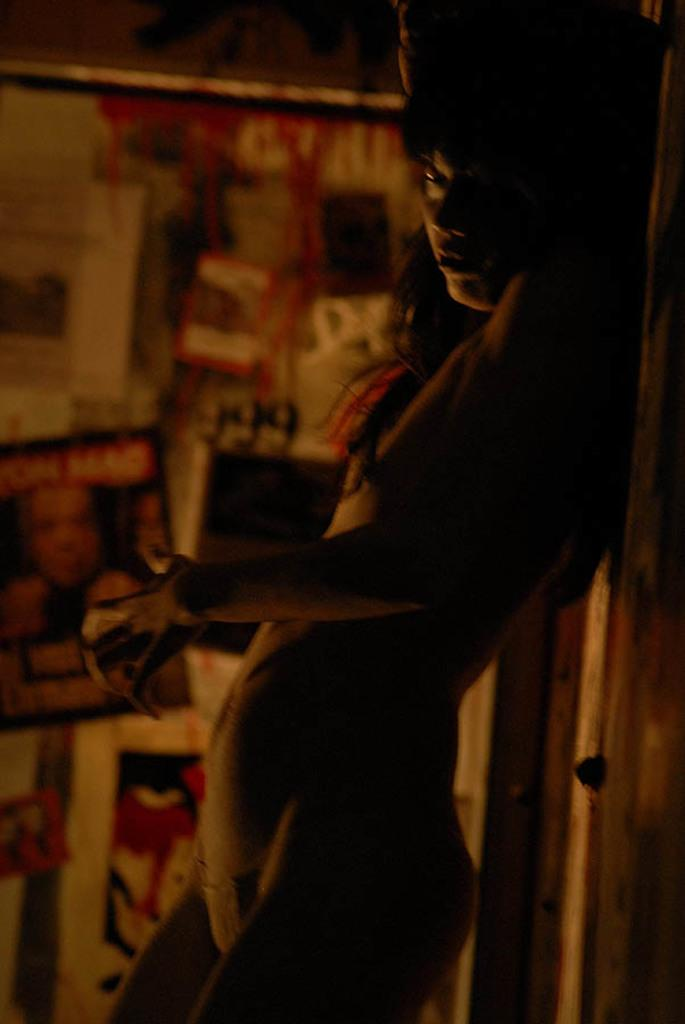What is the main subject of the image? There is a person standing in the image. Where is the person located in the image? The person is on the right side of the image. Can you describe the background of the image? The background of the image is blurred. What type of crime is being committed in the image? There is no crime being committed in the image; it simply features a person standing on the right side with a blurred background. 